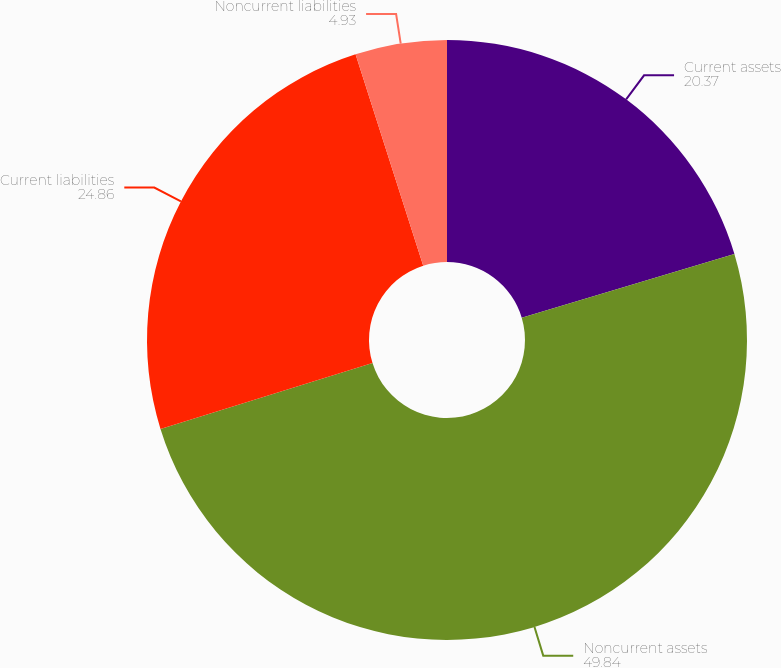Convert chart to OTSL. <chart><loc_0><loc_0><loc_500><loc_500><pie_chart><fcel>Current assets<fcel>Noncurrent assets<fcel>Current liabilities<fcel>Noncurrent liabilities<nl><fcel>20.37%<fcel>49.84%<fcel>24.86%<fcel>4.93%<nl></chart> 